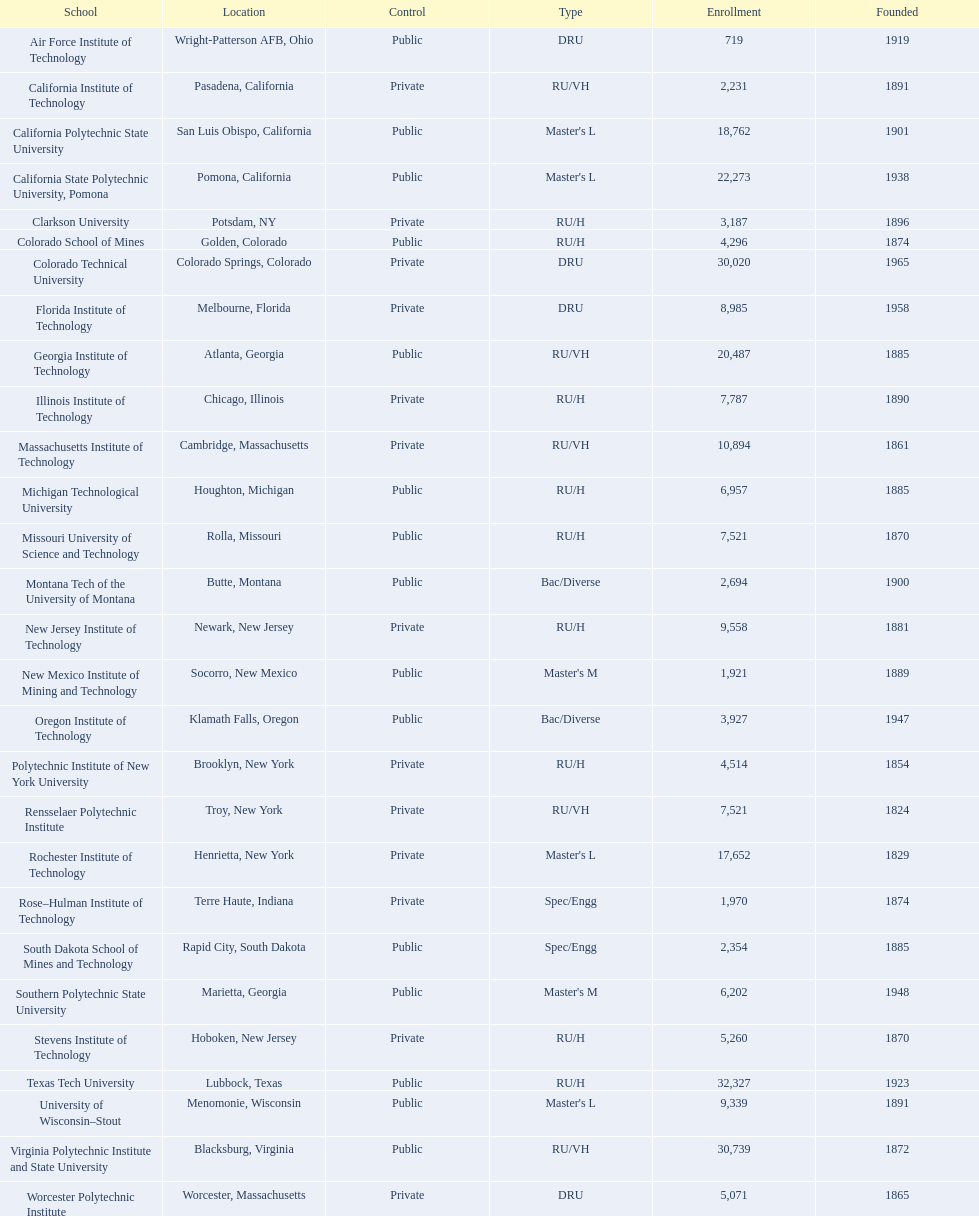What school is listed next after michigan technological university? Missouri University of Science and Technology. 